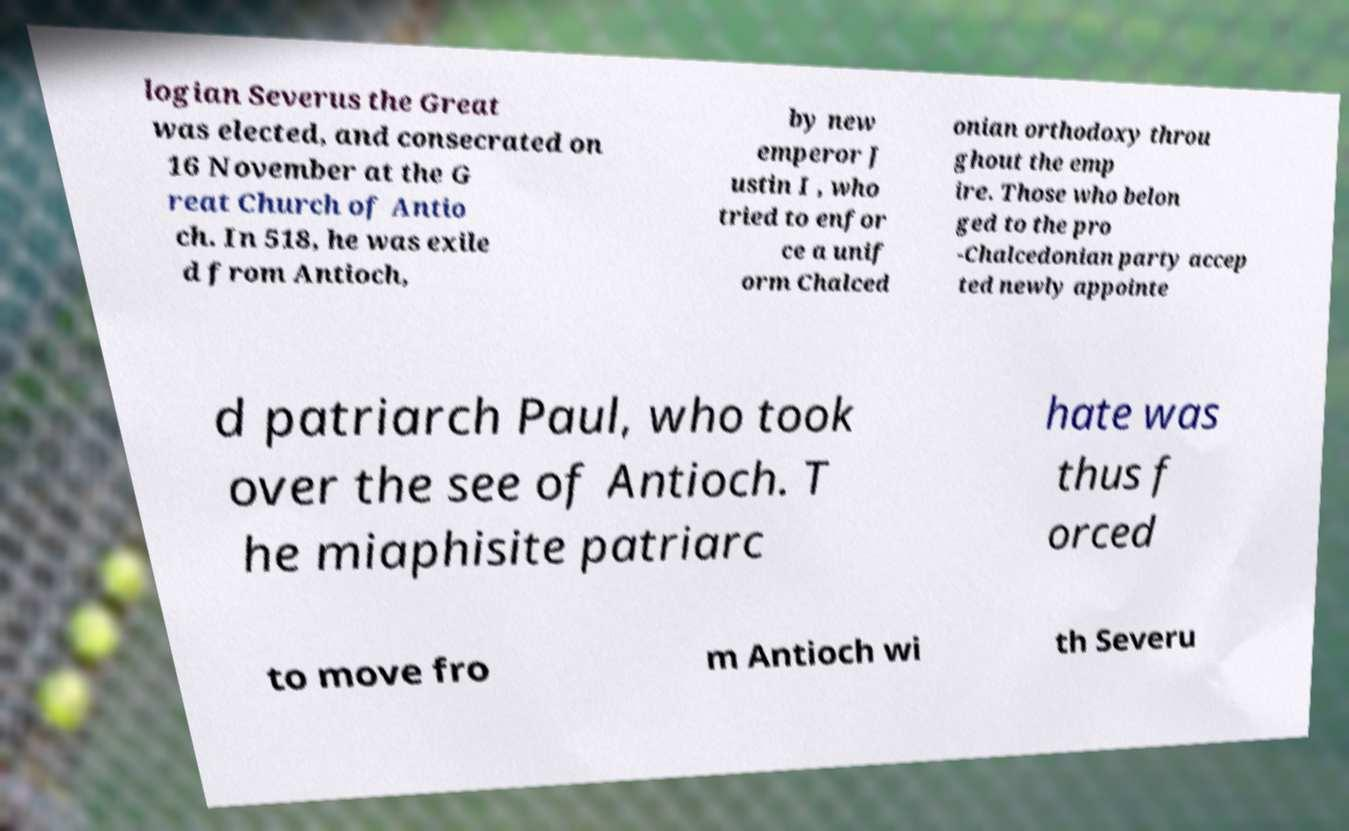For documentation purposes, I need the text within this image transcribed. Could you provide that? logian Severus the Great was elected, and consecrated on 16 November at the G reat Church of Antio ch. In 518, he was exile d from Antioch, by new emperor J ustin I , who tried to enfor ce a unif orm Chalced onian orthodoxy throu ghout the emp ire. Those who belon ged to the pro -Chalcedonian party accep ted newly appointe d patriarch Paul, who took over the see of Antioch. T he miaphisite patriarc hate was thus f orced to move fro m Antioch wi th Severu 